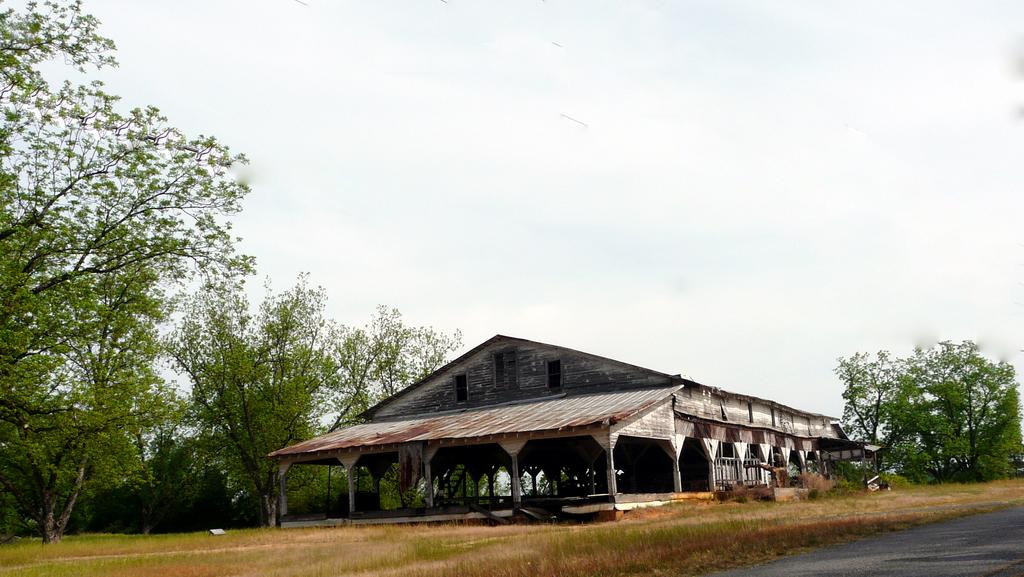What type of structure is in the image? There is a wooden shed in the image. What type of vegetation can be seen in the image? There is grass and trees in the image. What type of pathway is in the image? There is a road in the image. What is visible in the background of the image? The sky is visible in the image, and clouds are present in the sky. What arithmetic problem is being solved on the roof of the shed in the image? There is no arithmetic problem visible on the roof of the shed in the image. What type of coil is wrapped around the trees in the image? There are no coils wrapped around the trees in the image. 